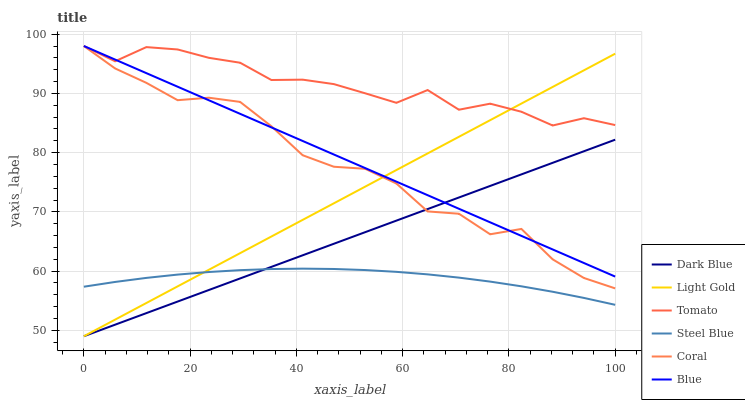Does Steel Blue have the minimum area under the curve?
Answer yes or no. Yes. Does Tomato have the maximum area under the curve?
Answer yes or no. Yes. Does Blue have the minimum area under the curve?
Answer yes or no. No. Does Blue have the maximum area under the curve?
Answer yes or no. No. Is Light Gold the smoothest?
Answer yes or no. Yes. Is Coral the roughest?
Answer yes or no. Yes. Is Blue the smoothest?
Answer yes or no. No. Is Blue the roughest?
Answer yes or no. No. Does Dark Blue have the lowest value?
Answer yes or no. Yes. Does Blue have the lowest value?
Answer yes or no. No. Does Coral have the highest value?
Answer yes or no. Yes. Does Steel Blue have the highest value?
Answer yes or no. No. Is Steel Blue less than Tomato?
Answer yes or no. Yes. Is Tomato greater than Steel Blue?
Answer yes or no. Yes. Does Coral intersect Dark Blue?
Answer yes or no. Yes. Is Coral less than Dark Blue?
Answer yes or no. No. Is Coral greater than Dark Blue?
Answer yes or no. No. Does Steel Blue intersect Tomato?
Answer yes or no. No. 